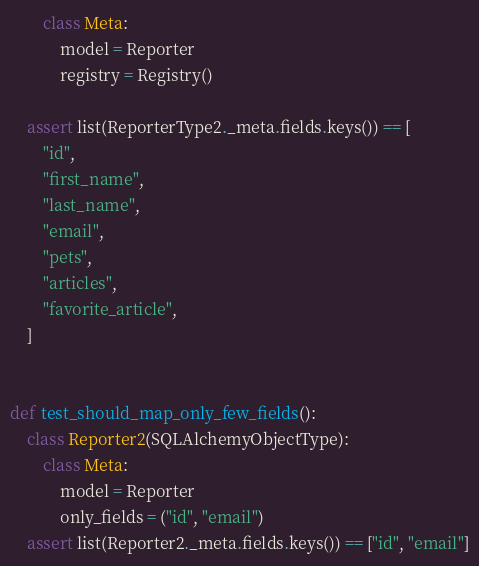<code> <loc_0><loc_0><loc_500><loc_500><_Python_>        class Meta:
            model = Reporter
            registry = Registry()

    assert list(ReporterType2._meta.fields.keys()) == [
        "id",
        "first_name",
        "last_name",
        "email",
        "pets",
        "articles",
        "favorite_article",
    ]


def test_should_map_only_few_fields():
    class Reporter2(SQLAlchemyObjectType):
        class Meta:
            model = Reporter
            only_fields = ("id", "email")
    assert list(Reporter2._meta.fields.keys()) == ["id", "email"]
</code> 